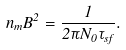Convert formula to latex. <formula><loc_0><loc_0><loc_500><loc_500>n _ { m } B ^ { 2 } = \frac { 1 } { 2 \pi N _ { 0 } \tau _ { s f } } .</formula> 